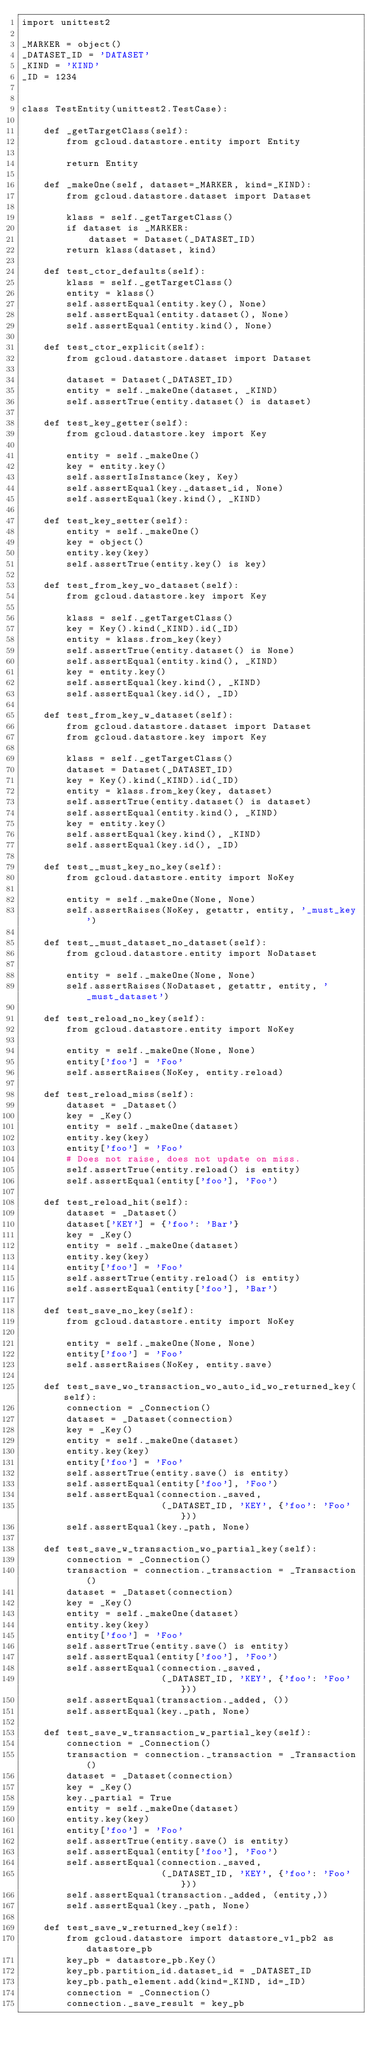Convert code to text. <code><loc_0><loc_0><loc_500><loc_500><_Python_>import unittest2

_MARKER = object()
_DATASET_ID = 'DATASET'
_KIND = 'KIND'
_ID = 1234


class TestEntity(unittest2.TestCase):

    def _getTargetClass(self):
        from gcloud.datastore.entity import Entity

        return Entity

    def _makeOne(self, dataset=_MARKER, kind=_KIND):
        from gcloud.datastore.dataset import Dataset

        klass = self._getTargetClass()
        if dataset is _MARKER:
            dataset = Dataset(_DATASET_ID)
        return klass(dataset, kind)

    def test_ctor_defaults(self):
        klass = self._getTargetClass()
        entity = klass()
        self.assertEqual(entity.key(), None)
        self.assertEqual(entity.dataset(), None)
        self.assertEqual(entity.kind(), None)

    def test_ctor_explicit(self):
        from gcloud.datastore.dataset import Dataset

        dataset = Dataset(_DATASET_ID)
        entity = self._makeOne(dataset, _KIND)
        self.assertTrue(entity.dataset() is dataset)

    def test_key_getter(self):
        from gcloud.datastore.key import Key

        entity = self._makeOne()
        key = entity.key()
        self.assertIsInstance(key, Key)
        self.assertEqual(key._dataset_id, None)
        self.assertEqual(key.kind(), _KIND)

    def test_key_setter(self):
        entity = self._makeOne()
        key = object()
        entity.key(key)
        self.assertTrue(entity.key() is key)

    def test_from_key_wo_dataset(self):
        from gcloud.datastore.key import Key

        klass = self._getTargetClass()
        key = Key().kind(_KIND).id(_ID)
        entity = klass.from_key(key)
        self.assertTrue(entity.dataset() is None)
        self.assertEqual(entity.kind(), _KIND)
        key = entity.key()
        self.assertEqual(key.kind(), _KIND)
        self.assertEqual(key.id(), _ID)

    def test_from_key_w_dataset(self):
        from gcloud.datastore.dataset import Dataset
        from gcloud.datastore.key import Key

        klass = self._getTargetClass()
        dataset = Dataset(_DATASET_ID)
        key = Key().kind(_KIND).id(_ID)
        entity = klass.from_key(key, dataset)
        self.assertTrue(entity.dataset() is dataset)
        self.assertEqual(entity.kind(), _KIND)
        key = entity.key()
        self.assertEqual(key.kind(), _KIND)
        self.assertEqual(key.id(), _ID)

    def test__must_key_no_key(self):
        from gcloud.datastore.entity import NoKey

        entity = self._makeOne(None, None)
        self.assertRaises(NoKey, getattr, entity, '_must_key')

    def test__must_dataset_no_dataset(self):
        from gcloud.datastore.entity import NoDataset

        entity = self._makeOne(None, None)
        self.assertRaises(NoDataset, getattr, entity, '_must_dataset')

    def test_reload_no_key(self):
        from gcloud.datastore.entity import NoKey

        entity = self._makeOne(None, None)
        entity['foo'] = 'Foo'
        self.assertRaises(NoKey, entity.reload)

    def test_reload_miss(self):
        dataset = _Dataset()
        key = _Key()
        entity = self._makeOne(dataset)
        entity.key(key)
        entity['foo'] = 'Foo'
        # Does not raise, does not update on miss.
        self.assertTrue(entity.reload() is entity)
        self.assertEqual(entity['foo'], 'Foo')

    def test_reload_hit(self):
        dataset = _Dataset()
        dataset['KEY'] = {'foo': 'Bar'}
        key = _Key()
        entity = self._makeOne(dataset)
        entity.key(key)
        entity['foo'] = 'Foo'
        self.assertTrue(entity.reload() is entity)
        self.assertEqual(entity['foo'], 'Bar')

    def test_save_no_key(self):
        from gcloud.datastore.entity import NoKey

        entity = self._makeOne(None, None)
        entity['foo'] = 'Foo'
        self.assertRaises(NoKey, entity.save)

    def test_save_wo_transaction_wo_auto_id_wo_returned_key(self):
        connection = _Connection()
        dataset = _Dataset(connection)
        key = _Key()
        entity = self._makeOne(dataset)
        entity.key(key)
        entity['foo'] = 'Foo'
        self.assertTrue(entity.save() is entity)
        self.assertEqual(entity['foo'], 'Foo')
        self.assertEqual(connection._saved,
                         (_DATASET_ID, 'KEY', {'foo': 'Foo'}))
        self.assertEqual(key._path, None)

    def test_save_w_transaction_wo_partial_key(self):
        connection = _Connection()
        transaction = connection._transaction = _Transaction()
        dataset = _Dataset(connection)
        key = _Key()
        entity = self._makeOne(dataset)
        entity.key(key)
        entity['foo'] = 'Foo'
        self.assertTrue(entity.save() is entity)
        self.assertEqual(entity['foo'], 'Foo')
        self.assertEqual(connection._saved,
                         (_DATASET_ID, 'KEY', {'foo': 'Foo'}))
        self.assertEqual(transaction._added, ())
        self.assertEqual(key._path, None)

    def test_save_w_transaction_w_partial_key(self):
        connection = _Connection()
        transaction = connection._transaction = _Transaction()
        dataset = _Dataset(connection)
        key = _Key()
        key._partial = True
        entity = self._makeOne(dataset)
        entity.key(key)
        entity['foo'] = 'Foo'
        self.assertTrue(entity.save() is entity)
        self.assertEqual(entity['foo'], 'Foo')
        self.assertEqual(connection._saved,
                         (_DATASET_ID, 'KEY', {'foo': 'Foo'}))
        self.assertEqual(transaction._added, (entity,))
        self.assertEqual(key._path, None)

    def test_save_w_returned_key(self):
        from gcloud.datastore import datastore_v1_pb2 as datastore_pb
        key_pb = datastore_pb.Key()
        key_pb.partition_id.dataset_id = _DATASET_ID
        key_pb.path_element.add(kind=_KIND, id=_ID)
        connection = _Connection()
        connection._save_result = key_pb</code> 